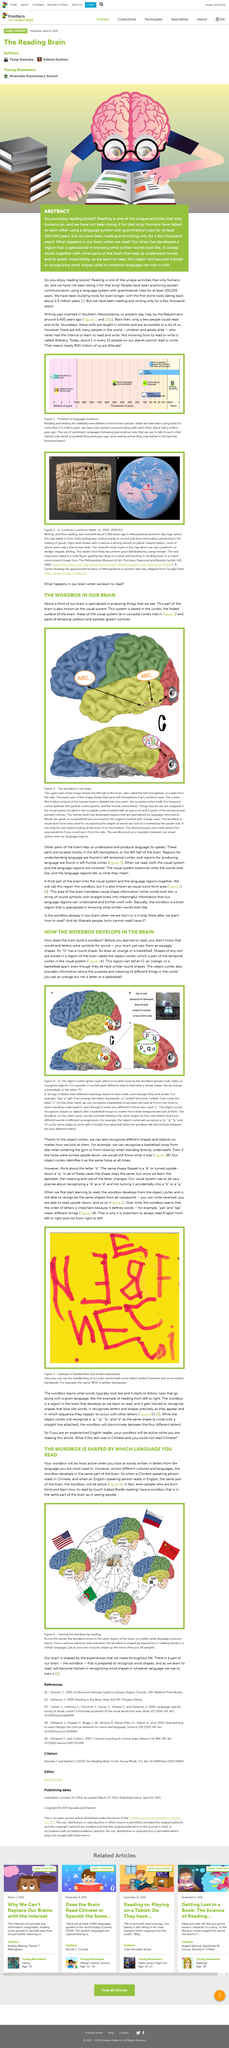Specify some key components in this picture. When reading, a specific part of the brain is activated, known as the wordbox. The object cortex provides information about the purpose and meaning of different things in the world. The brain has a region that is specialized in recognizing written words based on its physical appearance. The occipital cortex of the brain is shown in red in the figure below. The yellow part of the brain shown in the figure is the temporal cortices. 